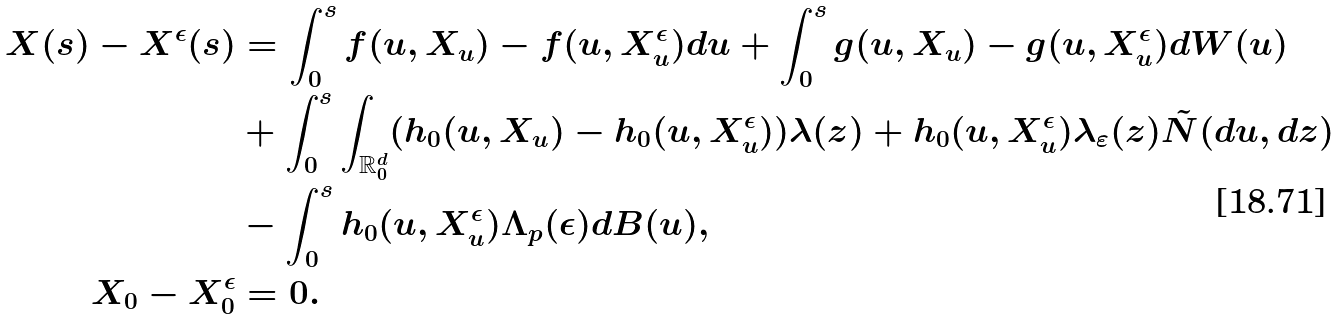<formula> <loc_0><loc_0><loc_500><loc_500>X ( s ) - X ^ { \epsilon } ( s ) & = \int _ { 0 } ^ { s } f ( u , X _ { u } ) - f ( u , X _ { u } ^ { \epsilon } ) d u + \int _ { 0 } ^ { s } g ( u , X _ { u } ) - g ( u , X _ { u } ^ { \epsilon } ) d W ( u ) \\ & + \int _ { 0 } ^ { s } \int _ { \mathbb { R } _ { 0 } ^ { d } } ( h _ { 0 } ( u , X _ { u } ) - h _ { 0 } ( u , X _ { u } ^ { \epsilon } ) ) \lambda ( z ) + h _ { 0 } ( u , X ^ { \epsilon } _ { u } ) \lambda _ { \varepsilon } ( z ) \tilde { N } ( d u , d z ) \\ & - \int _ { 0 } ^ { s } h _ { 0 } ( u , X _ { u } ^ { \epsilon } ) \Lambda _ { p } ( \epsilon ) d B ( u ) , \\ X _ { 0 } - X _ { 0 } ^ { \epsilon } & = 0 .</formula> 